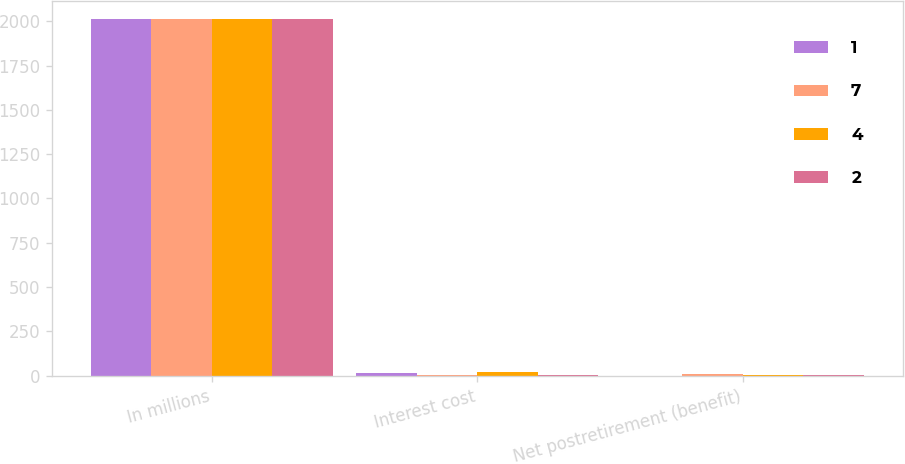Convert chart to OTSL. <chart><loc_0><loc_0><loc_500><loc_500><stacked_bar_chart><ecel><fcel>In millions<fcel>Interest cost<fcel>Net postretirement (benefit)<nl><fcel>1<fcel>2013<fcel>14<fcel>1<nl><fcel>7<fcel>2013<fcel>5<fcel>7<nl><fcel>4<fcel>2012<fcel>20<fcel>4<nl><fcel>2<fcel>2011<fcel>2<fcel>2<nl></chart> 